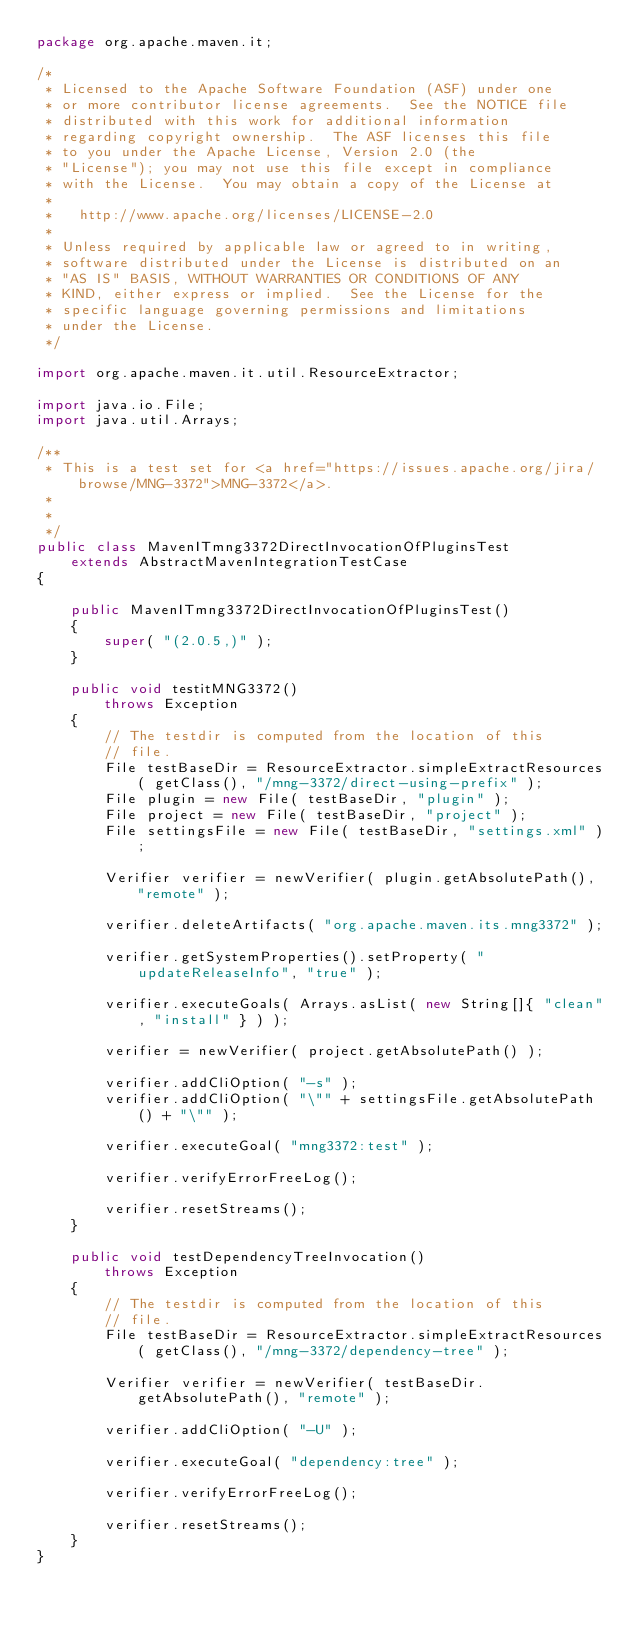<code> <loc_0><loc_0><loc_500><loc_500><_Java_>package org.apache.maven.it;

/*
 * Licensed to the Apache Software Foundation (ASF) under one
 * or more contributor license agreements.  See the NOTICE file
 * distributed with this work for additional information
 * regarding copyright ownership.  The ASF licenses this file
 * to you under the Apache License, Version 2.0 (the
 * "License"); you may not use this file except in compliance
 * with the License.  You may obtain a copy of the License at
 *
 *   http://www.apache.org/licenses/LICENSE-2.0
 *
 * Unless required by applicable law or agreed to in writing,
 * software distributed under the License is distributed on an
 * "AS IS" BASIS, WITHOUT WARRANTIES OR CONDITIONS OF ANY
 * KIND, either express or implied.  See the License for the
 * specific language governing permissions and limitations
 * under the License.
 */

import org.apache.maven.it.util.ResourceExtractor;

import java.io.File;
import java.util.Arrays;

/**
 * This is a test set for <a href="https://issues.apache.org/jira/browse/MNG-3372">MNG-3372</a>.
 *
 *
 */
public class MavenITmng3372DirectInvocationOfPluginsTest
    extends AbstractMavenIntegrationTestCase
{

    public MavenITmng3372DirectInvocationOfPluginsTest()
    {
        super( "(2.0.5,)" );
    }

    public void testitMNG3372()
        throws Exception
    {
        // The testdir is computed from the location of this
        // file.
        File testBaseDir = ResourceExtractor.simpleExtractResources( getClass(), "/mng-3372/direct-using-prefix" );
        File plugin = new File( testBaseDir, "plugin" );
        File project = new File( testBaseDir, "project" );
        File settingsFile = new File( testBaseDir, "settings.xml" );

        Verifier verifier = newVerifier( plugin.getAbsolutePath(), "remote" );

        verifier.deleteArtifacts( "org.apache.maven.its.mng3372" );

        verifier.getSystemProperties().setProperty( "updateReleaseInfo", "true" );

        verifier.executeGoals( Arrays.asList( new String[]{ "clean", "install" } ) );

        verifier = newVerifier( project.getAbsolutePath() );

        verifier.addCliOption( "-s" );
        verifier.addCliOption( "\"" + settingsFile.getAbsolutePath() + "\"" );

        verifier.executeGoal( "mng3372:test" );

        verifier.verifyErrorFreeLog();

        verifier.resetStreams();
    }

    public void testDependencyTreeInvocation()
        throws Exception
    {
        // The testdir is computed from the location of this
        // file.
        File testBaseDir = ResourceExtractor.simpleExtractResources( getClass(), "/mng-3372/dependency-tree" );

        Verifier verifier = newVerifier( testBaseDir.getAbsolutePath(), "remote" );

        verifier.addCliOption( "-U" );

        verifier.executeGoal( "dependency:tree" );

        verifier.verifyErrorFreeLog();

        verifier.resetStreams();
    }
}
</code> 